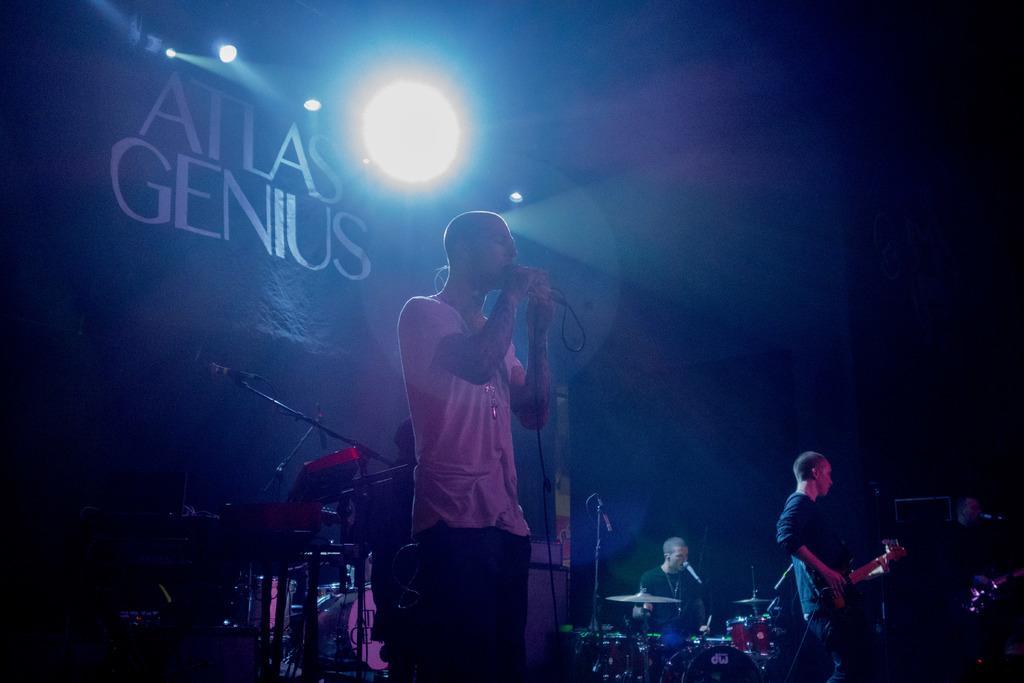How would you summarize this image in a sentence or two? In the image I can see a person who is holding the mic and to the side there are some other people who are playing some musical instruments and behind there is a banner and some lights. 